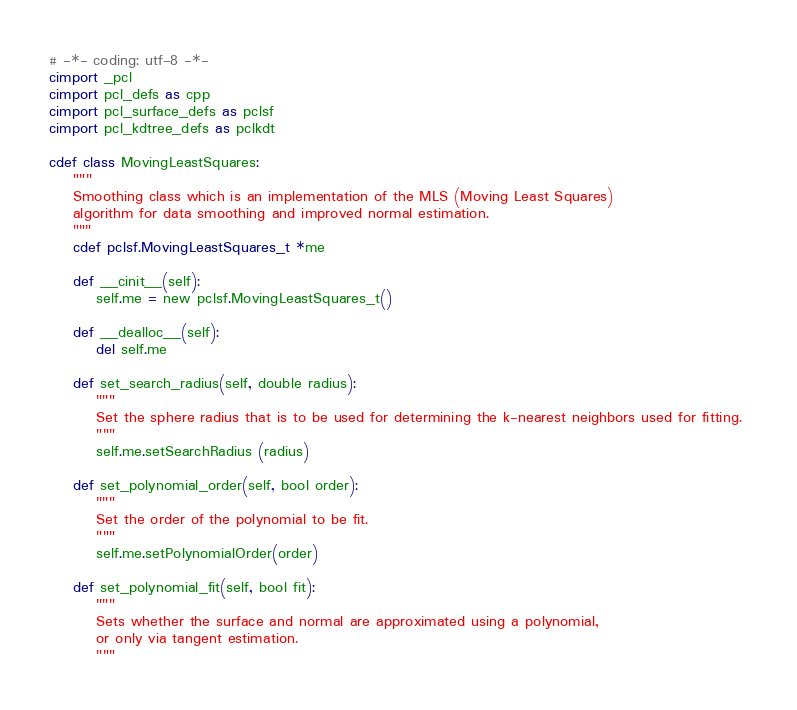<code> <loc_0><loc_0><loc_500><loc_500><_Cython_># -*- coding: utf-8 -*-
cimport _pcl
cimport pcl_defs as cpp
cimport pcl_surface_defs as pclsf
cimport pcl_kdtree_defs as pclkdt

cdef class MovingLeastSquares:
    """
    Smoothing class which is an implementation of the MLS (Moving Least Squares)
    algorithm for data smoothing and improved normal estimation.
    """
    cdef pclsf.MovingLeastSquares_t *me
    
    def __cinit__(self):
        self.me = new pclsf.MovingLeastSquares_t()
    
    def __dealloc__(self):
        del self.me
    
    def set_search_radius(self, double radius):
        """
        Set the sphere radius that is to be used for determining the k-nearest neighbors used for fitting. 
        """
        self.me.setSearchRadius (radius)
    
    def set_polynomial_order(self, bool order):
        """
        Set the order of the polynomial to be fit. 
        """
        self.me.setPolynomialOrder(order)
    
    def set_polynomial_fit(self, bool fit):
        """
        Sets whether the surface and normal are approximated using a polynomial,
        or only via tangent estimation.
        """</code> 